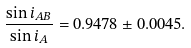Convert formula to latex. <formula><loc_0><loc_0><loc_500><loc_500>\frac { \sin i _ { A B } } { \sin i _ { A } } = 0 . 9 4 7 8 \pm 0 . 0 0 4 5 .</formula> 